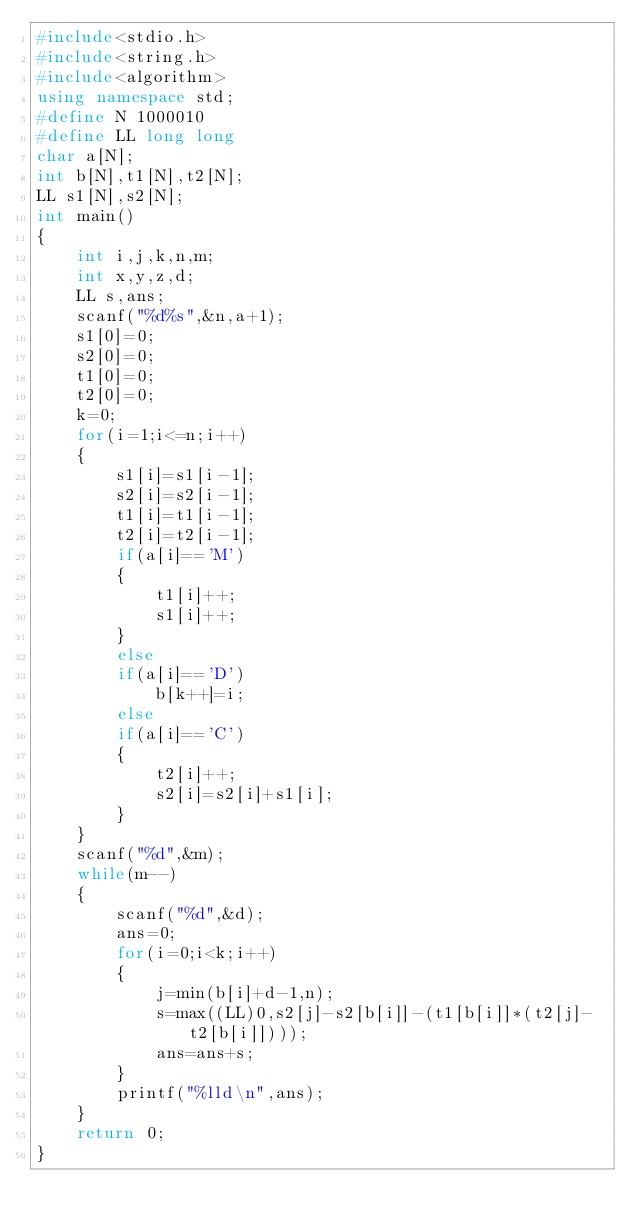Convert code to text. <code><loc_0><loc_0><loc_500><loc_500><_C++_>#include<stdio.h>
#include<string.h>
#include<algorithm>
using namespace std;
#define N 1000010
#define LL long long
char a[N];
int b[N],t1[N],t2[N];
LL s1[N],s2[N];
int main()
{
    int i,j,k,n,m;
    int x,y,z,d;
    LL s,ans;
    scanf("%d%s",&n,a+1);
    s1[0]=0;
    s2[0]=0;
    t1[0]=0;
    t2[0]=0;
    k=0;
    for(i=1;i<=n;i++)
    {
        s1[i]=s1[i-1];
        s2[i]=s2[i-1];
        t1[i]=t1[i-1];
        t2[i]=t2[i-1];
        if(a[i]=='M')
        {
            t1[i]++;
            s1[i]++;
        }
        else
        if(a[i]=='D')
            b[k++]=i;
        else
        if(a[i]=='C')
        {
            t2[i]++;
            s2[i]=s2[i]+s1[i];
        }
    }
    scanf("%d",&m);
    while(m--)
    {
        scanf("%d",&d);
        ans=0;
        for(i=0;i<k;i++)
        {
            j=min(b[i]+d-1,n);
            s=max((LL)0,s2[j]-s2[b[i]]-(t1[b[i]]*(t2[j]-t2[b[i]])));
            ans=ans+s;
        }
        printf("%lld\n",ans);
    }
    return 0;
}
</code> 